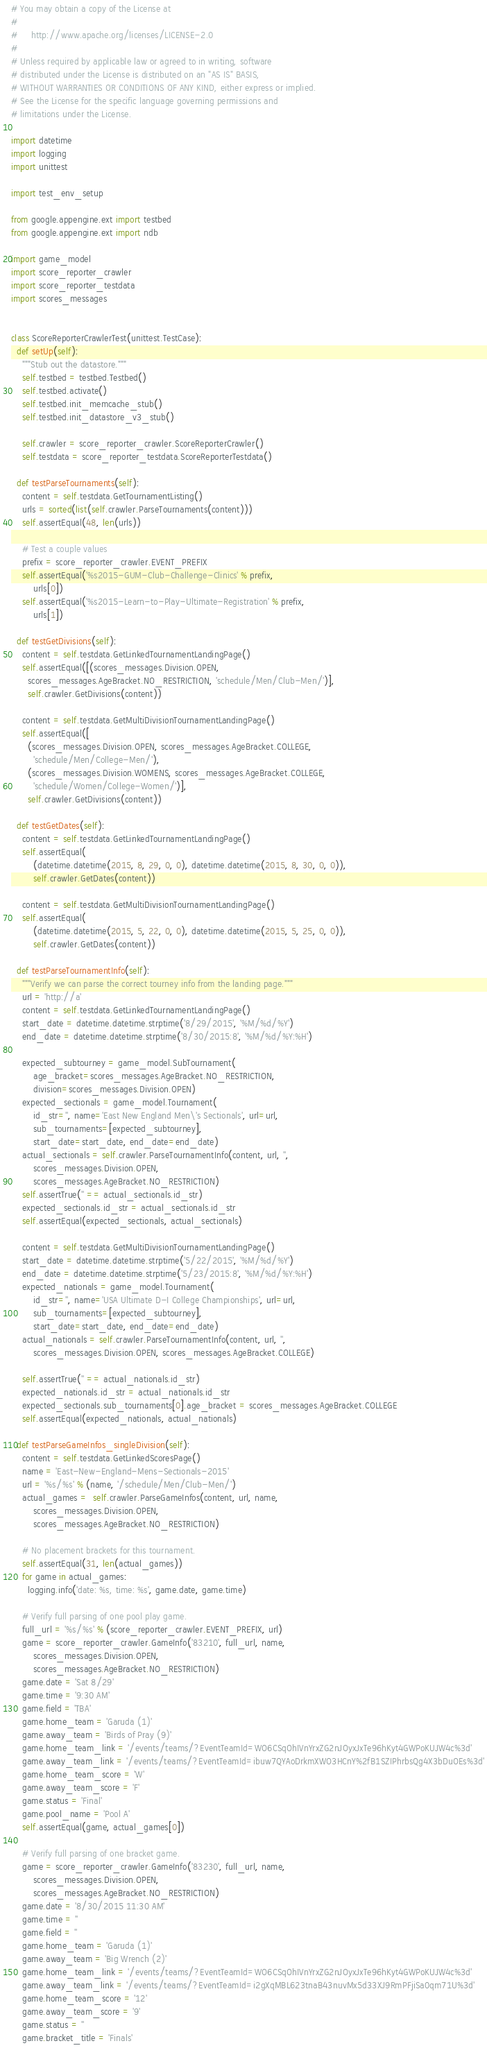Convert code to text. <code><loc_0><loc_0><loc_500><loc_500><_Python_># You may obtain a copy of the License at
#
#     http://www.apache.org/licenses/LICENSE-2.0
#
# Unless required by applicable law or agreed to in writing, software
# distributed under the License is distributed on an "AS IS" BASIS,
# WITHOUT WARRANTIES OR CONDITIONS OF ANY KIND, either express or implied.
# See the License for the specific language governing permissions and
# limitations under the License.

import datetime
import logging
import unittest

import test_env_setup

from google.appengine.ext import testbed
from google.appengine.ext import ndb

import game_model
import score_reporter_crawler
import score_reporter_testdata
import scores_messages


class ScoreReporterCrawlerTest(unittest.TestCase):
  def setUp(self):
    """Stub out the datastore."""
    self.testbed = testbed.Testbed()
    self.testbed.activate()
    self.testbed.init_memcache_stub()
    self.testbed.init_datastore_v3_stub()

    self.crawler = score_reporter_crawler.ScoreReporterCrawler()
    self.testdata = score_reporter_testdata.ScoreReporterTestdata()

  def testParseTournaments(self):
    content = self.testdata.GetTournamentListing()
    urls = sorted(list(self.crawler.ParseTournaments(content)))
    self.assertEqual(48, len(urls))

    # Test a couple values
    prefix = score_reporter_crawler.EVENT_PREFIX
    self.assertEqual('%s2015-GUM-Club-Challenge-Clinics' % prefix,
        urls[0])
    self.assertEqual('%s2015-Learn-to-Play-Ultimate-Registration' % prefix,
        urls[1])

  def testGetDivisions(self):
    content = self.testdata.GetLinkedTournamentLandingPage()
    self.assertEqual([(scores_messages.Division.OPEN,
      scores_messages.AgeBracket.NO_RESTRICTION, 'schedule/Men/Club-Men/')],
      self.crawler.GetDivisions(content))

    content = self.testdata.GetMultiDivisionTournamentLandingPage()
    self.assertEqual([
      (scores_messages.Division.OPEN, scores_messages.AgeBracket.COLLEGE,
        'schedule/Men/College-Men/'),
      (scores_messages.Division.WOMENS, scores_messages.AgeBracket.COLLEGE,
        'schedule/Women/College-Women/')],
      self.crawler.GetDivisions(content))

  def testGetDates(self):
    content = self.testdata.GetLinkedTournamentLandingPage()
    self.assertEqual(
        (datetime.datetime(2015, 8, 29, 0, 0), datetime.datetime(2015, 8, 30, 0, 0)),
        self.crawler.GetDates(content))

    content = self.testdata.GetMultiDivisionTournamentLandingPage()
    self.assertEqual(
        (datetime.datetime(2015, 5, 22, 0, 0), datetime.datetime(2015, 5, 25, 0, 0)),
        self.crawler.GetDates(content))

  def testParseTournamentInfo(self):
    """Verify we can parse the correct tourney info from the landing page."""
    url = 'http://a'
    content = self.testdata.GetLinkedTournamentLandingPage()
    start_date = datetime.datetime.strptime('8/29/2015', '%M/%d/%Y')
    end_date = datetime.datetime.strptime('8/30/2015:8', '%M/%d/%Y:%H')

    expected_subtourney = game_model.SubTournament(
        age_bracket=scores_messages.AgeBracket.NO_RESTRICTION,
        division=scores_messages.Division.OPEN)
    expected_sectionals = game_model.Tournament(
        id_str='', name='East New England Men\'s Sectionals', url=url,
        sub_tournaments=[expected_subtourney],
        start_date=start_date, end_date=end_date)
    actual_sectionals = self.crawler.ParseTournamentInfo(content, url, '',
        scores_messages.Division.OPEN,
        scores_messages.AgeBracket.NO_RESTRICTION)
    self.assertTrue('' == actual_sectionals.id_str)
    expected_sectionals.id_str = actual_sectionals.id_str
    self.assertEqual(expected_sectionals, actual_sectionals)

    content = self.testdata.GetMultiDivisionTournamentLandingPage()
    start_date = datetime.datetime.strptime('5/22/2015', '%M/%d/%Y')
    end_date = datetime.datetime.strptime('5/23/2015:8', '%M/%d/%Y:%H')
    expected_nationals = game_model.Tournament(
        id_str='', name='USA Ultimate D-I College Championships', url=url,
        sub_tournaments=[expected_subtourney],
        start_date=start_date, end_date=end_date)
    actual_nationals = self.crawler.ParseTournamentInfo(content, url, '',
        scores_messages.Division.OPEN, scores_messages.AgeBracket.COLLEGE)

    self.assertTrue('' == actual_nationals.id_str)
    expected_nationals.id_str = actual_nationals.id_str
    expected_sectionals.sub_tournaments[0].age_bracket = scores_messages.AgeBracket.COLLEGE
    self.assertEqual(expected_nationals, actual_nationals)

  def testParseGameInfos_singleDivision(self):
    content = self.testdata.GetLinkedScoresPage()
    name = 'East-New-England-Mens-Sectionals-2015'
    url = '%s/%s' % (name, '/schedule/Men/Club-Men/')
    actual_games =  self.crawler.ParseGameInfos(content, url, name,
        scores_messages.Division.OPEN,
        scores_messages.AgeBracket.NO_RESTRICTION)

    # No placement brackets for this tournament.
    self.assertEqual(31, len(actual_games))
    for game in actual_games:
      logging.info('date: %s, time: %s', game.date, game.time)

    # Verify full parsing of one pool play game.
    full_url = '%s/%s' % (score_reporter_crawler.EVENT_PREFIX, url)
    game = score_reporter_crawler.GameInfo('83210', full_url, name,
        scores_messages.Division.OPEN,
        scores_messages.AgeBracket.NO_RESTRICTION)
    game.date = 'Sat 8/29'
    game.time = '9:30 AM'
    game.field = 'TBA'
    game.home_team = 'Garuda (1)'
    game.away_team = 'Birds of Pray (9)'
    game.home_team_link = '/events/teams/?EventTeamId=WO6CSqOhIVnYrxZG2nJOyxJxTe96hKyt4GWPoKUJW4c%3d'
    game.away_team_link = '/events/teams/?EventTeamId=ibuw7QYAoDrkmXWO3HCnY%2fB1SZIPhrbsQg4X3bDuOEs%3d'
    game.home_team_score = 'W'
    game.away_team_score = 'F'
    game.status = 'Final'
    game.pool_name = 'Pool A'
    self.assertEqual(game, actual_games[0])

    # Verify full parsing of one bracket game.
    game = score_reporter_crawler.GameInfo('83230', full_url, name,
        scores_messages.Division.OPEN,
        scores_messages.AgeBracket.NO_RESTRICTION)
    game.date = '8/30/2015 11:30 AM'
    game.time = ''
    game.field = ''
    game.home_team = 'Garuda (1)'
    game.away_team = 'Big Wrench (2)'
    game.home_team_link = '/events/teams/?EventTeamId=WO6CSqOhIVnYrxZG2nJOyxJxTe96hKyt4GWPoKUJW4c%3d'
    game.away_team_link = '/events/teams/?EventTeamId=i2gXqMBL623tnaB43nuvMx5d33XJ9RmPFjiSa0qm71U%3d'
    game.home_team_score = '12'
    game.away_team_score = '9'
    game.status = ''
    game.bracket_title = 'Finals'</code> 